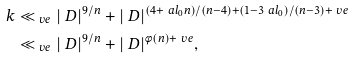Convert formula to latex. <formula><loc_0><loc_0><loc_500><loc_500>k & \ll _ { \ v e } | \ D | ^ { 9 / n } + | \ D | ^ { ( 4 + \ a l _ { 0 } n ) / ( n - 4 ) + ( 1 - 3 \ a l _ { 0 } ) / ( n - 3 ) + \ v e } \\ & \ll _ { \ v e } | \ D | ^ { 9 / n } + | \ D | ^ { \phi ( n ) + \ v e } ,</formula> 